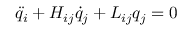Convert formula to latex. <formula><loc_0><loc_0><loc_500><loc_500>\ddot { q } _ { i } + H _ { i j } \dot { q } _ { j } + L _ { i j } q _ { j } = 0</formula> 